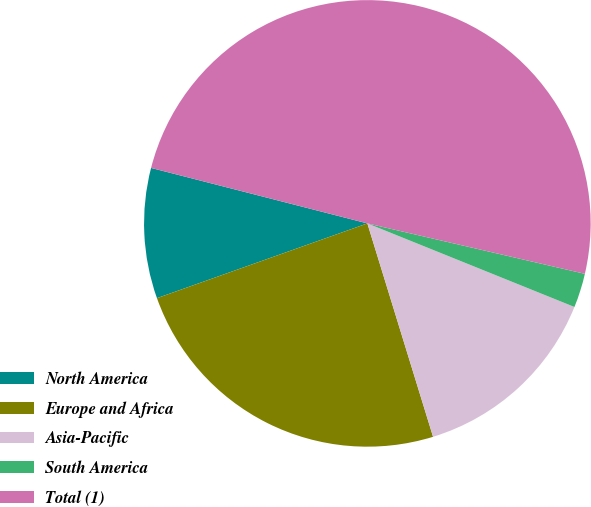Convert chart to OTSL. <chart><loc_0><loc_0><loc_500><loc_500><pie_chart><fcel>North America<fcel>Europe and Africa<fcel>Asia-Pacific<fcel>South America<fcel>Total (1)<nl><fcel>9.43%<fcel>24.32%<fcel>14.14%<fcel>2.48%<fcel>49.63%<nl></chart> 